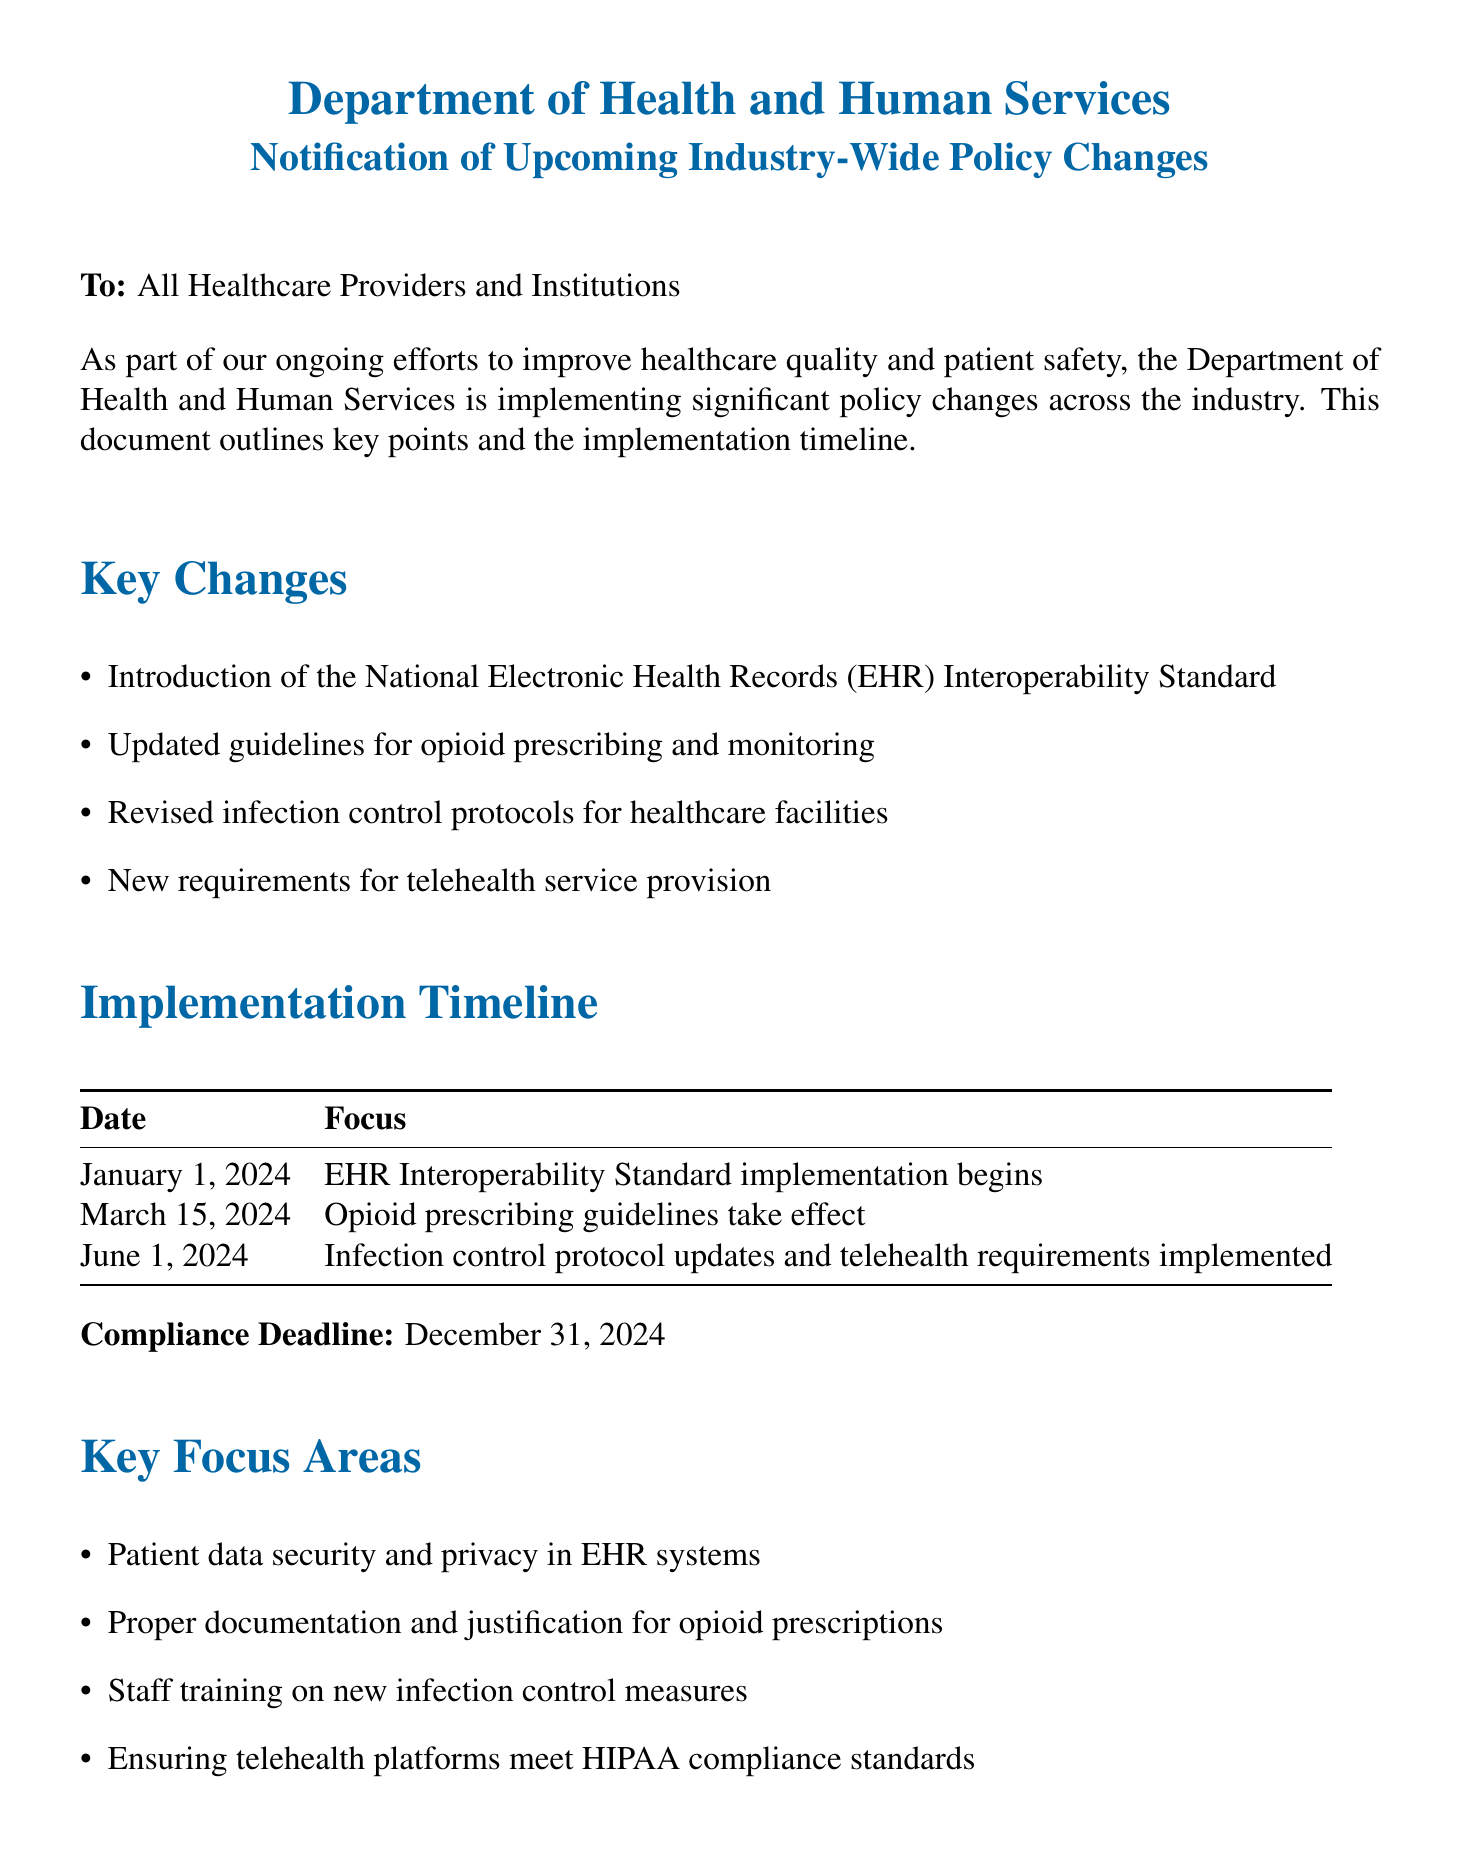What is the title of the document? The title of the document is provided at the beginning and identifies the subject, which is "Notification of Upcoming Industry-Wide Policy Changes."
Answer: Notification of Upcoming Industry-Wide Policy Changes Who is the sender of the document? The sender is indicated at the top, stating it is from the Department of Health and Human Services.
Answer: Department of Health and Human Services When does the implementation of the EHR Interoperability Standard begin? The implementation date for the EHR Interoperability Standard is explicitly stated in the timeline section of the document.
Answer: January 1, 2024 What is the compliance deadline for the new policies? The compliance deadline is specified clearly to ensure recipients adhere to the new policies by a certain date.
Answer: December 31, 2024 What is one of the key focus areas regarding telehealth? The document lists specific focus areas, one of which is related to telehealth standards that must be met.
Answer: HIPAA compliance standards What new requirement is mentioned for opioid prescribing? The document highlights updated guidelines for opioid prescribing which require specific practices to be adapted.
Answer: Proper documentation and justification Which key change relates to infection control protocols? The document mentions revised infection control protocols specifically as part of the key changes introduced.
Answer: Revised infection control protocols What resource is provided for assistance? The document lists several resources for recipients to seek assistance, including a helpline.
Answer: 1-800-HHS-HELP 